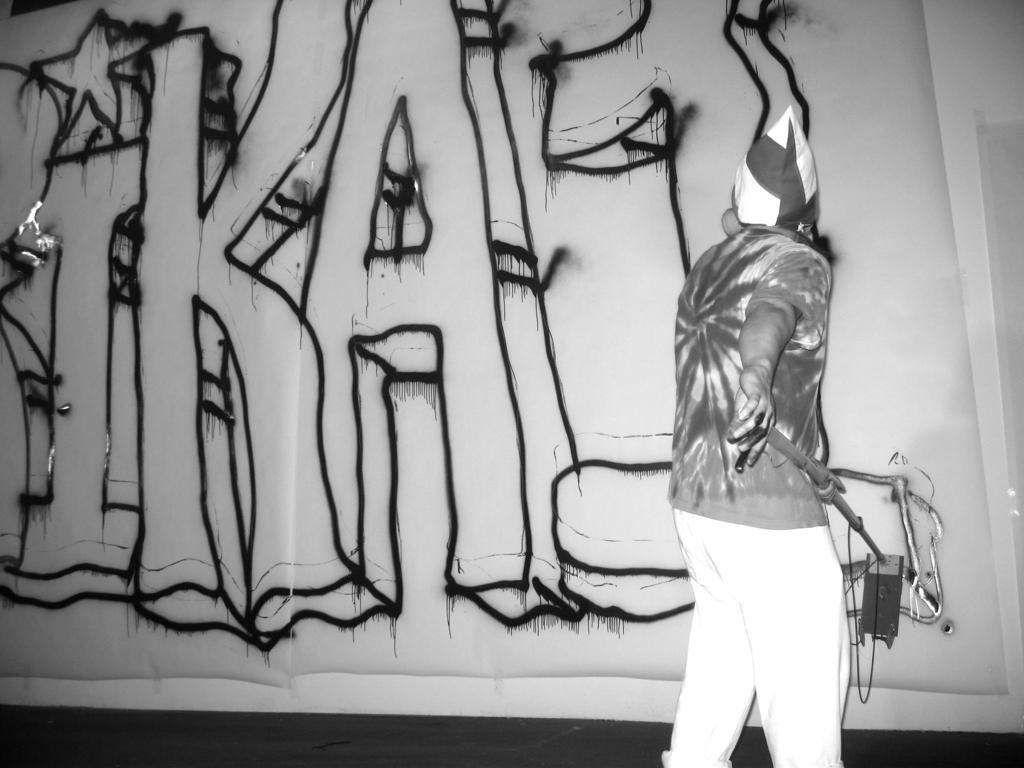Could you give a brief overview of what you see in this image? In this image I can see a person standing and holding something. I can see a wall and something is written on it. The image is in black and white. 